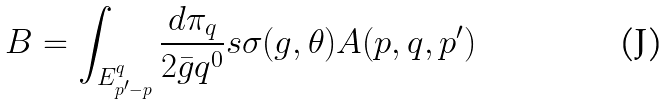Convert formula to latex. <formula><loc_0><loc_0><loc_500><loc_500>B = \int _ { E ^ { q } _ { p ^ { \prime } - p } } \frac { d \pi _ { q } } { 2 \bar { g } { q ^ { 0 } } } s \sigma ( g , \theta ) A ( p , q , p ^ { \prime } )</formula> 